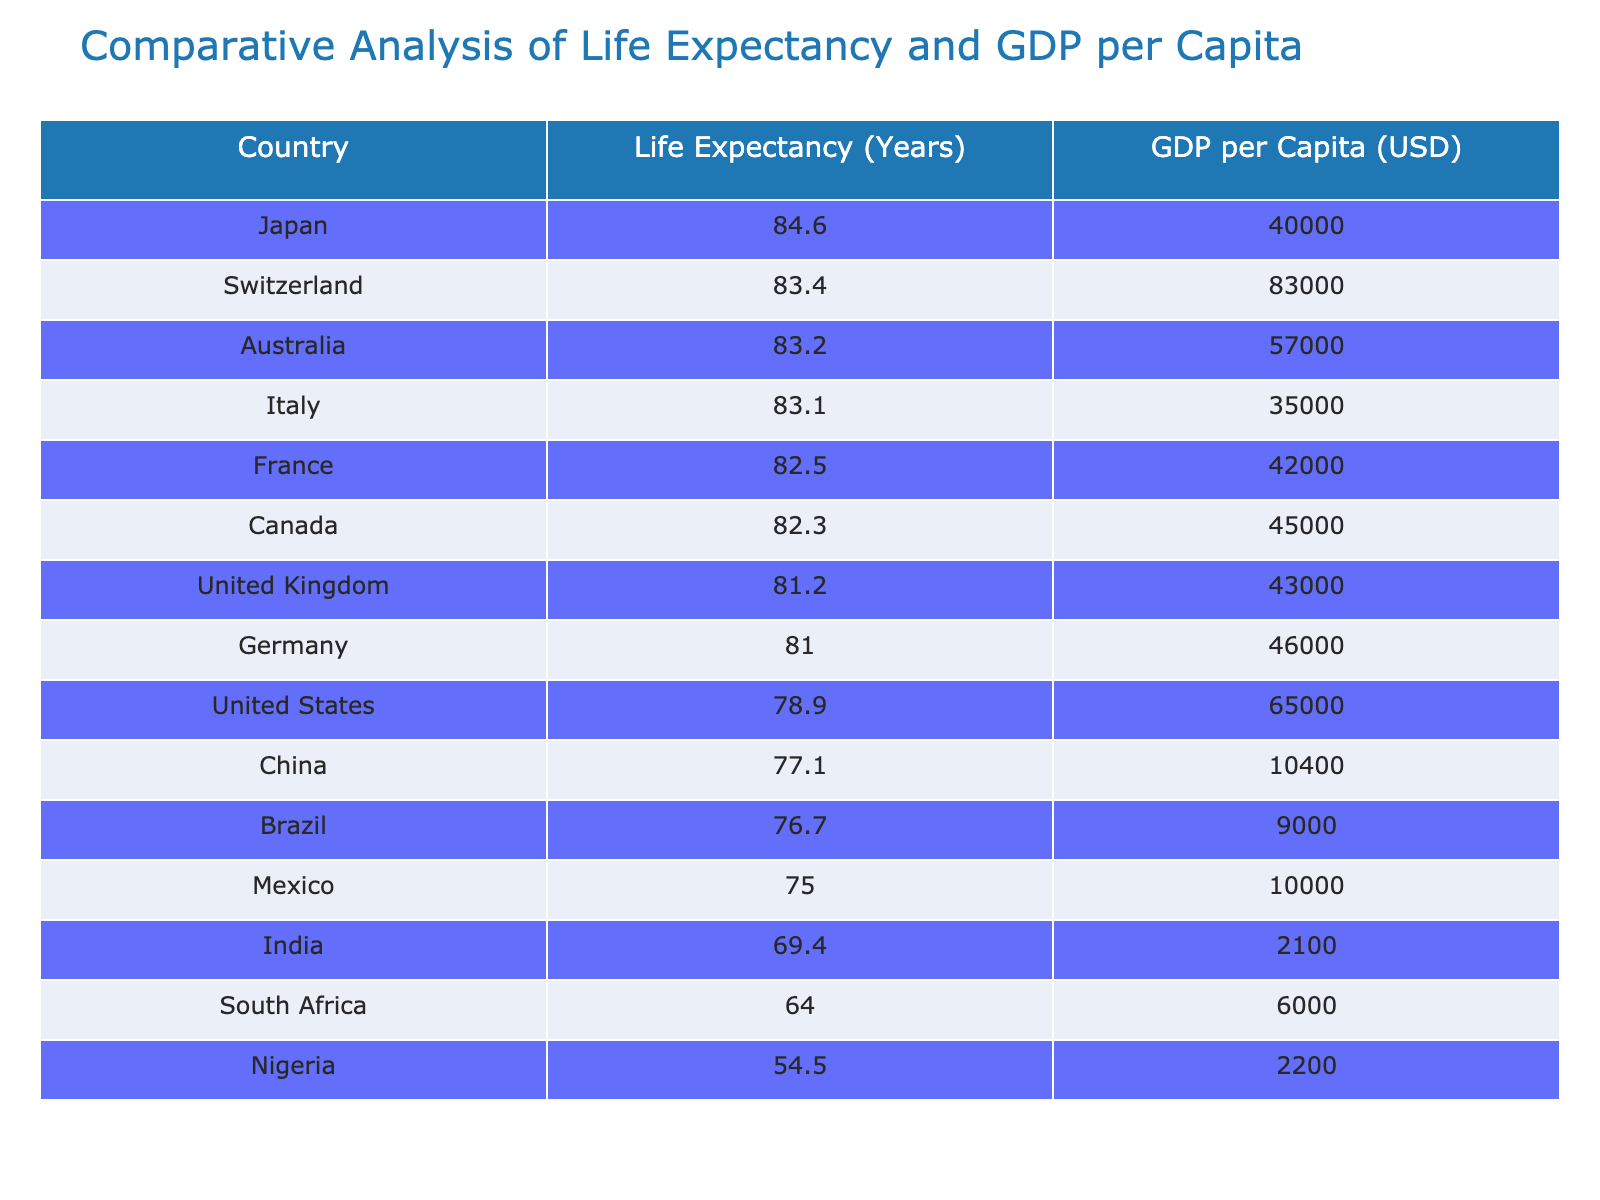What is the life expectancy of Japan? The life expectancy of Japan is directly listed in the table under the corresponding country. Japan's life expectancy is shown as 84.6 years.
Answer: 84.6 years Which country has the lowest GDP per capita? By scanning the GDP per capita column, Nigeria shows the lowest value at 2200 USD, thus being the country with the lowest GDP per capita in the table.
Answer: 2200 USD What is the difference in life expectancy between Switzerland and Brazil? Switzerland has a life expectancy of 83.4 years and Brazil has 76.7 years. The difference is calculated as 83.4 - 76.7 = 6.7 years.
Answer: 6.7 years Is the life expectancy of the United States greater than that of South Africa? The life expectancy of the United States is 78.9 years, while South Africa's is 64.0 years. Since 78.9 is greater than 64.0, the statement is true.
Answer: Yes What is the average life expectancy of the countries listed in the table? To find the average life expectancy, first add the life expectancies: 84.6 + 83.4 + 83.2 + 81.0 + 82.3 + 78.9 + 81.2 + 82.5 + 83.1 + 76.7 + 69.4 + 54.5 + 64.0 + 77.1 + 75.0 = 1228.6. There are 15 countries, so average = 1228.6 / 15 = 81.91 years.
Answer: 81.91 years Which countries have a life expectancy above 80 years? By examining the life expectancy column, we find that Japan, Switzerland, Australia, Canada, Germany, United Kingdom, France, and Italy all have a life expectancy above 80 years. These are 8 countries.
Answer: 8 countries 